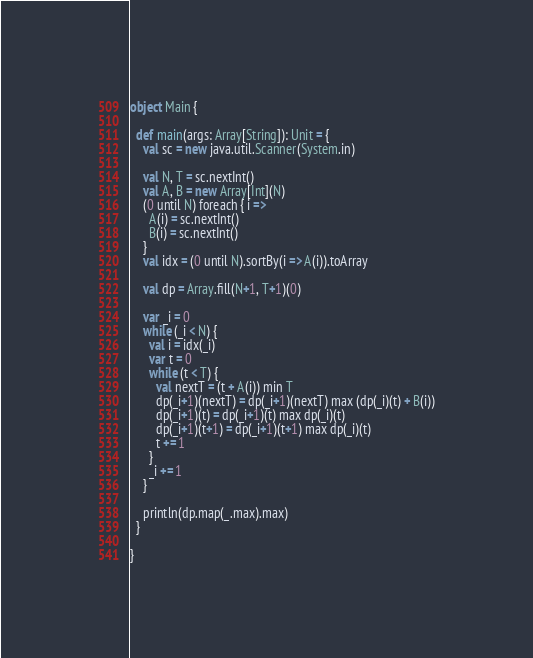Convert code to text. <code><loc_0><loc_0><loc_500><loc_500><_Scala_>object Main {

  def main(args: Array[String]): Unit = {
    val sc = new java.util.Scanner(System.in)

    val N, T = sc.nextInt()
    val A, B = new Array[Int](N)
    (0 until N) foreach { i =>
      A(i) = sc.nextInt()
      B(i) = sc.nextInt()
    }
    val idx = (0 until N).sortBy(i => A(i)).toArray

    val dp = Array.fill(N+1, T+1)(0)

    var _i = 0
    while (_i < N) {
      val i = idx(_i)
      var t = 0
      while (t < T) {
        val nextT = (t + A(i)) min T
        dp(_i+1)(nextT) = dp(_i+1)(nextT) max (dp(_i)(t) + B(i))
        dp(_i+1)(t) = dp(_i+1)(t) max dp(_i)(t)
        dp(_i+1)(t+1) = dp(_i+1)(t+1) max dp(_i)(t)
        t += 1
      }
      _i += 1
    }

    println(dp.map(_.max).max)
  }

}
</code> 